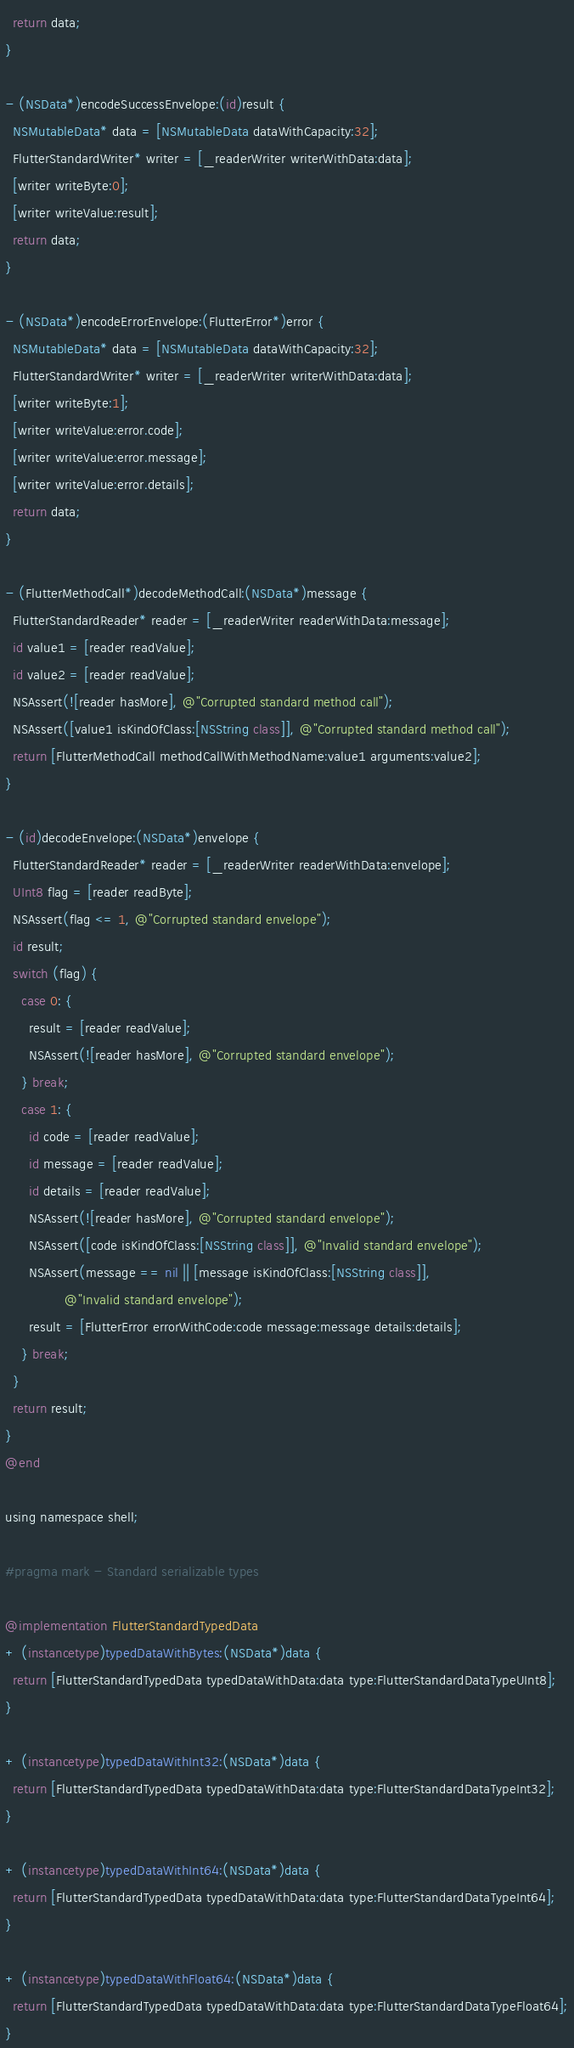<code> <loc_0><loc_0><loc_500><loc_500><_ObjectiveC_>  return data;
}

- (NSData*)encodeSuccessEnvelope:(id)result {
  NSMutableData* data = [NSMutableData dataWithCapacity:32];
  FlutterStandardWriter* writer = [_readerWriter writerWithData:data];
  [writer writeByte:0];
  [writer writeValue:result];
  return data;
}

- (NSData*)encodeErrorEnvelope:(FlutterError*)error {
  NSMutableData* data = [NSMutableData dataWithCapacity:32];
  FlutterStandardWriter* writer = [_readerWriter writerWithData:data];
  [writer writeByte:1];
  [writer writeValue:error.code];
  [writer writeValue:error.message];
  [writer writeValue:error.details];
  return data;
}

- (FlutterMethodCall*)decodeMethodCall:(NSData*)message {
  FlutterStandardReader* reader = [_readerWriter readerWithData:message];
  id value1 = [reader readValue];
  id value2 = [reader readValue];
  NSAssert(![reader hasMore], @"Corrupted standard method call");
  NSAssert([value1 isKindOfClass:[NSString class]], @"Corrupted standard method call");
  return [FlutterMethodCall methodCallWithMethodName:value1 arguments:value2];
}

- (id)decodeEnvelope:(NSData*)envelope {
  FlutterStandardReader* reader = [_readerWriter readerWithData:envelope];
  UInt8 flag = [reader readByte];
  NSAssert(flag <= 1, @"Corrupted standard envelope");
  id result;
  switch (flag) {
    case 0: {
      result = [reader readValue];
      NSAssert(![reader hasMore], @"Corrupted standard envelope");
    } break;
    case 1: {
      id code = [reader readValue];
      id message = [reader readValue];
      id details = [reader readValue];
      NSAssert(![reader hasMore], @"Corrupted standard envelope");
      NSAssert([code isKindOfClass:[NSString class]], @"Invalid standard envelope");
      NSAssert(message == nil || [message isKindOfClass:[NSString class]],
               @"Invalid standard envelope");
      result = [FlutterError errorWithCode:code message:message details:details];
    } break;
  }
  return result;
}
@end

using namespace shell;

#pragma mark - Standard serializable types

@implementation FlutterStandardTypedData
+ (instancetype)typedDataWithBytes:(NSData*)data {
  return [FlutterStandardTypedData typedDataWithData:data type:FlutterStandardDataTypeUInt8];
}

+ (instancetype)typedDataWithInt32:(NSData*)data {
  return [FlutterStandardTypedData typedDataWithData:data type:FlutterStandardDataTypeInt32];
}

+ (instancetype)typedDataWithInt64:(NSData*)data {
  return [FlutterStandardTypedData typedDataWithData:data type:FlutterStandardDataTypeInt64];
}

+ (instancetype)typedDataWithFloat64:(NSData*)data {
  return [FlutterStandardTypedData typedDataWithData:data type:FlutterStandardDataTypeFloat64];
}
</code> 